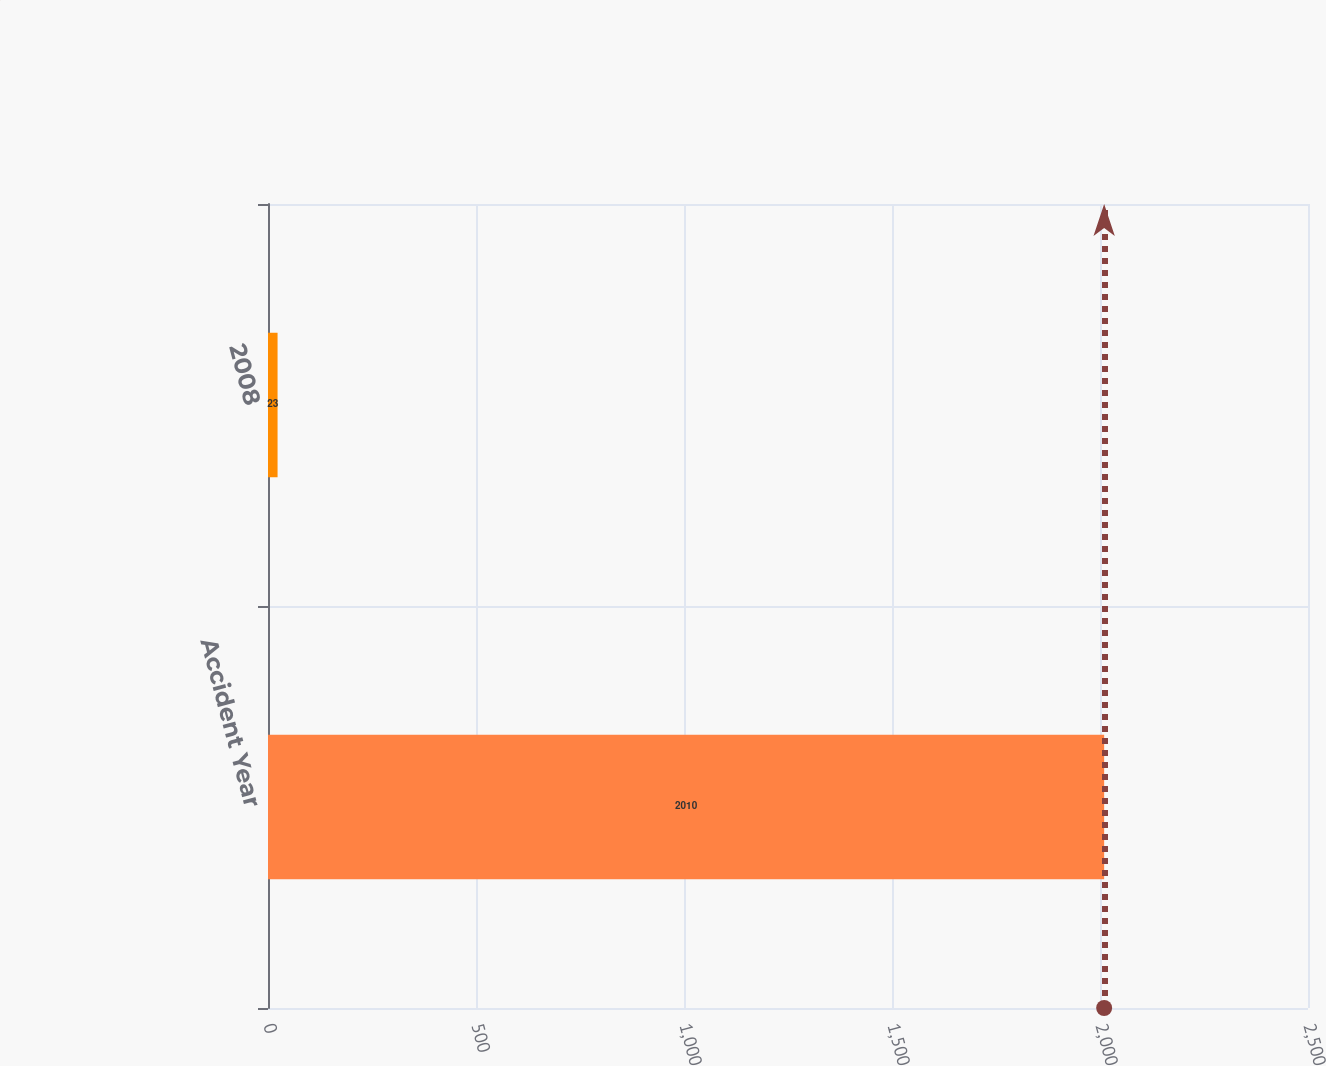Convert chart to OTSL. <chart><loc_0><loc_0><loc_500><loc_500><bar_chart><fcel>Accident Year<fcel>2008<nl><fcel>2010<fcel>23<nl></chart> 